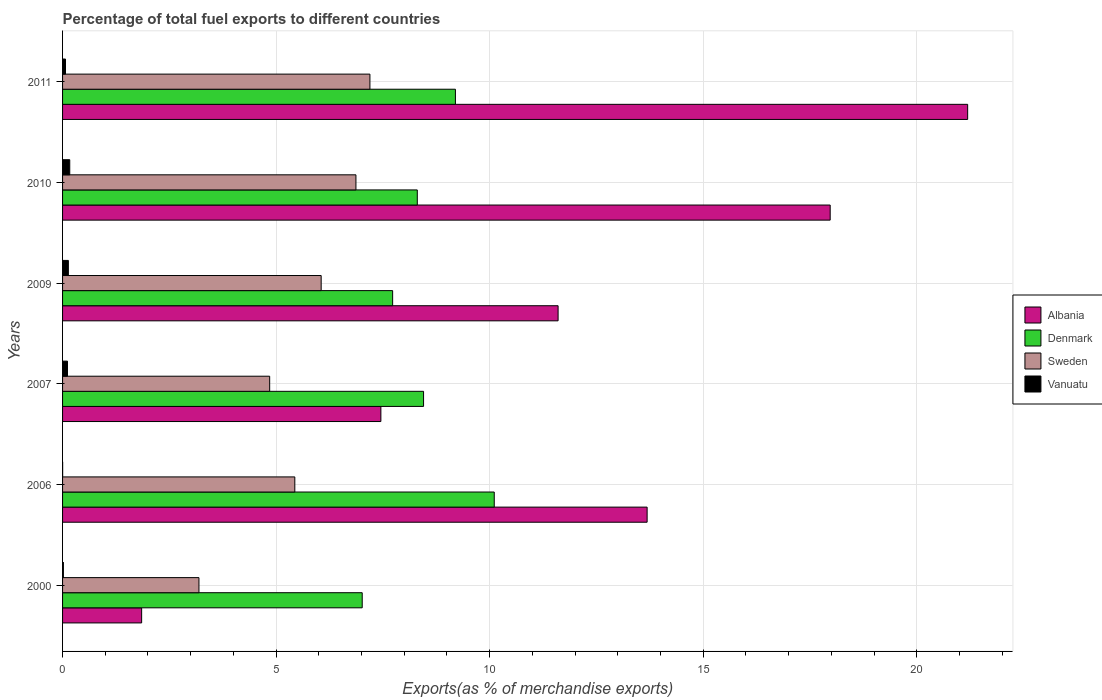How many groups of bars are there?
Your answer should be compact. 6. How many bars are there on the 1st tick from the top?
Give a very brief answer. 4. What is the percentage of exports to different countries in Sweden in 2010?
Offer a very short reply. 6.87. Across all years, what is the maximum percentage of exports to different countries in Albania?
Provide a short and direct response. 21.19. Across all years, what is the minimum percentage of exports to different countries in Sweden?
Offer a very short reply. 3.19. In which year was the percentage of exports to different countries in Sweden maximum?
Keep it short and to the point. 2011. In which year was the percentage of exports to different countries in Denmark minimum?
Your response must be concise. 2000. What is the total percentage of exports to different countries in Denmark in the graph?
Provide a succinct answer. 50.81. What is the difference between the percentage of exports to different countries in Vanuatu in 2006 and that in 2007?
Ensure brevity in your answer.  -0.11. What is the difference between the percentage of exports to different countries in Vanuatu in 2010 and the percentage of exports to different countries in Denmark in 2007?
Keep it short and to the point. -8.28. What is the average percentage of exports to different countries in Sweden per year?
Make the answer very short. 5.6. In the year 2000, what is the difference between the percentage of exports to different countries in Denmark and percentage of exports to different countries in Sweden?
Offer a very short reply. 3.82. What is the ratio of the percentage of exports to different countries in Sweden in 2000 to that in 2011?
Your answer should be compact. 0.44. Is the percentage of exports to different countries in Albania in 2000 less than that in 2010?
Your response must be concise. Yes. What is the difference between the highest and the second highest percentage of exports to different countries in Sweden?
Give a very brief answer. 0.33. What is the difference between the highest and the lowest percentage of exports to different countries in Denmark?
Keep it short and to the point. 3.09. Is it the case that in every year, the sum of the percentage of exports to different countries in Vanuatu and percentage of exports to different countries in Sweden is greater than the sum of percentage of exports to different countries in Albania and percentage of exports to different countries in Denmark?
Offer a very short reply. No. What does the 1st bar from the bottom in 2010 represents?
Offer a terse response. Albania. How many bars are there?
Your response must be concise. 24. What is the difference between two consecutive major ticks on the X-axis?
Your response must be concise. 5. Are the values on the major ticks of X-axis written in scientific E-notation?
Offer a very short reply. No. Does the graph contain any zero values?
Give a very brief answer. No. Does the graph contain grids?
Provide a short and direct response. Yes. How are the legend labels stacked?
Make the answer very short. Vertical. What is the title of the graph?
Your response must be concise. Percentage of total fuel exports to different countries. Does "Qatar" appear as one of the legend labels in the graph?
Provide a short and direct response. No. What is the label or title of the X-axis?
Provide a short and direct response. Exports(as % of merchandise exports). What is the label or title of the Y-axis?
Your response must be concise. Years. What is the Exports(as % of merchandise exports) of Albania in 2000?
Provide a short and direct response. 1.85. What is the Exports(as % of merchandise exports) of Denmark in 2000?
Offer a very short reply. 7.02. What is the Exports(as % of merchandise exports) of Sweden in 2000?
Your answer should be very brief. 3.19. What is the Exports(as % of merchandise exports) in Vanuatu in 2000?
Make the answer very short. 0.02. What is the Exports(as % of merchandise exports) of Albania in 2006?
Your answer should be compact. 13.69. What is the Exports(as % of merchandise exports) in Denmark in 2006?
Provide a short and direct response. 10.11. What is the Exports(as % of merchandise exports) of Sweden in 2006?
Make the answer very short. 5.44. What is the Exports(as % of merchandise exports) of Vanuatu in 2006?
Your answer should be compact. 0. What is the Exports(as % of merchandise exports) of Albania in 2007?
Ensure brevity in your answer.  7.45. What is the Exports(as % of merchandise exports) in Denmark in 2007?
Provide a short and direct response. 8.45. What is the Exports(as % of merchandise exports) of Sweden in 2007?
Ensure brevity in your answer.  4.85. What is the Exports(as % of merchandise exports) of Vanuatu in 2007?
Offer a very short reply. 0.12. What is the Exports(as % of merchandise exports) in Albania in 2009?
Your answer should be very brief. 11.6. What is the Exports(as % of merchandise exports) in Denmark in 2009?
Keep it short and to the point. 7.73. What is the Exports(as % of merchandise exports) of Sweden in 2009?
Offer a very short reply. 6.05. What is the Exports(as % of merchandise exports) of Vanuatu in 2009?
Make the answer very short. 0.14. What is the Exports(as % of merchandise exports) in Albania in 2010?
Give a very brief answer. 17.97. What is the Exports(as % of merchandise exports) in Denmark in 2010?
Offer a very short reply. 8.31. What is the Exports(as % of merchandise exports) in Sweden in 2010?
Ensure brevity in your answer.  6.87. What is the Exports(as % of merchandise exports) of Vanuatu in 2010?
Give a very brief answer. 0.17. What is the Exports(as % of merchandise exports) of Albania in 2011?
Ensure brevity in your answer.  21.19. What is the Exports(as % of merchandise exports) of Denmark in 2011?
Make the answer very short. 9.2. What is the Exports(as % of merchandise exports) of Sweden in 2011?
Provide a succinct answer. 7.2. What is the Exports(as % of merchandise exports) in Vanuatu in 2011?
Offer a terse response. 0.07. Across all years, what is the maximum Exports(as % of merchandise exports) in Albania?
Your response must be concise. 21.19. Across all years, what is the maximum Exports(as % of merchandise exports) of Denmark?
Provide a succinct answer. 10.11. Across all years, what is the maximum Exports(as % of merchandise exports) of Sweden?
Your answer should be compact. 7.2. Across all years, what is the maximum Exports(as % of merchandise exports) of Vanuatu?
Make the answer very short. 0.17. Across all years, what is the minimum Exports(as % of merchandise exports) in Albania?
Provide a short and direct response. 1.85. Across all years, what is the minimum Exports(as % of merchandise exports) in Denmark?
Provide a short and direct response. 7.02. Across all years, what is the minimum Exports(as % of merchandise exports) in Sweden?
Ensure brevity in your answer.  3.19. Across all years, what is the minimum Exports(as % of merchandise exports) in Vanuatu?
Make the answer very short. 0. What is the total Exports(as % of merchandise exports) in Albania in the graph?
Give a very brief answer. 73.76. What is the total Exports(as % of merchandise exports) in Denmark in the graph?
Offer a terse response. 50.81. What is the total Exports(as % of merchandise exports) of Sweden in the graph?
Make the answer very short. 33.6. What is the total Exports(as % of merchandise exports) of Vanuatu in the graph?
Offer a terse response. 0.51. What is the difference between the Exports(as % of merchandise exports) of Albania in 2000 and that in 2006?
Offer a very short reply. -11.84. What is the difference between the Exports(as % of merchandise exports) in Denmark in 2000 and that in 2006?
Provide a short and direct response. -3.09. What is the difference between the Exports(as % of merchandise exports) in Sweden in 2000 and that in 2006?
Your answer should be very brief. -2.24. What is the difference between the Exports(as % of merchandise exports) of Vanuatu in 2000 and that in 2006?
Keep it short and to the point. 0.02. What is the difference between the Exports(as % of merchandise exports) of Albania in 2000 and that in 2007?
Give a very brief answer. -5.6. What is the difference between the Exports(as % of merchandise exports) of Denmark in 2000 and that in 2007?
Ensure brevity in your answer.  -1.44. What is the difference between the Exports(as % of merchandise exports) of Sweden in 2000 and that in 2007?
Give a very brief answer. -1.66. What is the difference between the Exports(as % of merchandise exports) of Vanuatu in 2000 and that in 2007?
Ensure brevity in your answer.  -0.1. What is the difference between the Exports(as % of merchandise exports) in Albania in 2000 and that in 2009?
Your answer should be very brief. -9.75. What is the difference between the Exports(as % of merchandise exports) of Denmark in 2000 and that in 2009?
Offer a very short reply. -0.71. What is the difference between the Exports(as % of merchandise exports) of Sweden in 2000 and that in 2009?
Your answer should be compact. -2.86. What is the difference between the Exports(as % of merchandise exports) in Vanuatu in 2000 and that in 2009?
Offer a very short reply. -0.12. What is the difference between the Exports(as % of merchandise exports) in Albania in 2000 and that in 2010?
Offer a very short reply. -16.12. What is the difference between the Exports(as % of merchandise exports) of Denmark in 2000 and that in 2010?
Offer a terse response. -1.29. What is the difference between the Exports(as % of merchandise exports) of Sweden in 2000 and that in 2010?
Provide a succinct answer. -3.68. What is the difference between the Exports(as % of merchandise exports) in Vanuatu in 2000 and that in 2010?
Offer a terse response. -0.15. What is the difference between the Exports(as % of merchandise exports) in Albania in 2000 and that in 2011?
Provide a succinct answer. -19.34. What is the difference between the Exports(as % of merchandise exports) in Denmark in 2000 and that in 2011?
Your answer should be compact. -2.18. What is the difference between the Exports(as % of merchandise exports) in Sweden in 2000 and that in 2011?
Your answer should be very brief. -4. What is the difference between the Exports(as % of merchandise exports) in Vanuatu in 2000 and that in 2011?
Your response must be concise. -0.05. What is the difference between the Exports(as % of merchandise exports) of Albania in 2006 and that in 2007?
Keep it short and to the point. 6.23. What is the difference between the Exports(as % of merchandise exports) of Denmark in 2006 and that in 2007?
Make the answer very short. 1.66. What is the difference between the Exports(as % of merchandise exports) of Sweden in 2006 and that in 2007?
Your answer should be compact. 0.59. What is the difference between the Exports(as % of merchandise exports) in Vanuatu in 2006 and that in 2007?
Your response must be concise. -0.11. What is the difference between the Exports(as % of merchandise exports) of Albania in 2006 and that in 2009?
Your answer should be very brief. 2.08. What is the difference between the Exports(as % of merchandise exports) of Denmark in 2006 and that in 2009?
Ensure brevity in your answer.  2.38. What is the difference between the Exports(as % of merchandise exports) in Sweden in 2006 and that in 2009?
Provide a short and direct response. -0.62. What is the difference between the Exports(as % of merchandise exports) in Vanuatu in 2006 and that in 2009?
Ensure brevity in your answer.  -0.13. What is the difference between the Exports(as % of merchandise exports) of Albania in 2006 and that in 2010?
Your answer should be compact. -4.29. What is the difference between the Exports(as % of merchandise exports) of Denmark in 2006 and that in 2010?
Provide a short and direct response. 1.8. What is the difference between the Exports(as % of merchandise exports) of Sweden in 2006 and that in 2010?
Provide a short and direct response. -1.43. What is the difference between the Exports(as % of merchandise exports) in Vanuatu in 2006 and that in 2010?
Keep it short and to the point. -0.17. What is the difference between the Exports(as % of merchandise exports) of Albania in 2006 and that in 2011?
Offer a terse response. -7.5. What is the difference between the Exports(as % of merchandise exports) in Sweden in 2006 and that in 2011?
Keep it short and to the point. -1.76. What is the difference between the Exports(as % of merchandise exports) of Vanuatu in 2006 and that in 2011?
Your response must be concise. -0.07. What is the difference between the Exports(as % of merchandise exports) in Albania in 2007 and that in 2009?
Offer a very short reply. -4.15. What is the difference between the Exports(as % of merchandise exports) of Denmark in 2007 and that in 2009?
Ensure brevity in your answer.  0.72. What is the difference between the Exports(as % of merchandise exports) in Sweden in 2007 and that in 2009?
Provide a short and direct response. -1.21. What is the difference between the Exports(as % of merchandise exports) in Vanuatu in 2007 and that in 2009?
Keep it short and to the point. -0.02. What is the difference between the Exports(as % of merchandise exports) in Albania in 2007 and that in 2010?
Your answer should be compact. -10.52. What is the difference between the Exports(as % of merchandise exports) of Denmark in 2007 and that in 2010?
Make the answer very short. 0.15. What is the difference between the Exports(as % of merchandise exports) in Sweden in 2007 and that in 2010?
Make the answer very short. -2.02. What is the difference between the Exports(as % of merchandise exports) in Vanuatu in 2007 and that in 2010?
Offer a very short reply. -0.05. What is the difference between the Exports(as % of merchandise exports) in Albania in 2007 and that in 2011?
Your answer should be very brief. -13.74. What is the difference between the Exports(as % of merchandise exports) of Denmark in 2007 and that in 2011?
Offer a very short reply. -0.75. What is the difference between the Exports(as % of merchandise exports) in Sweden in 2007 and that in 2011?
Offer a terse response. -2.35. What is the difference between the Exports(as % of merchandise exports) in Vanuatu in 2007 and that in 2011?
Offer a terse response. 0.05. What is the difference between the Exports(as % of merchandise exports) in Albania in 2009 and that in 2010?
Offer a terse response. -6.37. What is the difference between the Exports(as % of merchandise exports) of Denmark in 2009 and that in 2010?
Give a very brief answer. -0.58. What is the difference between the Exports(as % of merchandise exports) in Sweden in 2009 and that in 2010?
Your response must be concise. -0.81. What is the difference between the Exports(as % of merchandise exports) of Vanuatu in 2009 and that in 2010?
Ensure brevity in your answer.  -0.03. What is the difference between the Exports(as % of merchandise exports) in Albania in 2009 and that in 2011?
Provide a succinct answer. -9.59. What is the difference between the Exports(as % of merchandise exports) of Denmark in 2009 and that in 2011?
Keep it short and to the point. -1.47. What is the difference between the Exports(as % of merchandise exports) in Sweden in 2009 and that in 2011?
Make the answer very short. -1.14. What is the difference between the Exports(as % of merchandise exports) in Vanuatu in 2009 and that in 2011?
Give a very brief answer. 0.07. What is the difference between the Exports(as % of merchandise exports) of Albania in 2010 and that in 2011?
Your answer should be compact. -3.22. What is the difference between the Exports(as % of merchandise exports) in Denmark in 2010 and that in 2011?
Give a very brief answer. -0.89. What is the difference between the Exports(as % of merchandise exports) in Sweden in 2010 and that in 2011?
Ensure brevity in your answer.  -0.33. What is the difference between the Exports(as % of merchandise exports) of Vanuatu in 2010 and that in 2011?
Your answer should be very brief. 0.1. What is the difference between the Exports(as % of merchandise exports) of Albania in 2000 and the Exports(as % of merchandise exports) of Denmark in 2006?
Provide a short and direct response. -8.26. What is the difference between the Exports(as % of merchandise exports) in Albania in 2000 and the Exports(as % of merchandise exports) in Sweden in 2006?
Offer a terse response. -3.59. What is the difference between the Exports(as % of merchandise exports) of Albania in 2000 and the Exports(as % of merchandise exports) of Vanuatu in 2006?
Ensure brevity in your answer.  1.85. What is the difference between the Exports(as % of merchandise exports) in Denmark in 2000 and the Exports(as % of merchandise exports) in Sweden in 2006?
Your answer should be very brief. 1.58. What is the difference between the Exports(as % of merchandise exports) in Denmark in 2000 and the Exports(as % of merchandise exports) in Vanuatu in 2006?
Offer a terse response. 7.01. What is the difference between the Exports(as % of merchandise exports) of Sweden in 2000 and the Exports(as % of merchandise exports) of Vanuatu in 2006?
Keep it short and to the point. 3.19. What is the difference between the Exports(as % of merchandise exports) in Albania in 2000 and the Exports(as % of merchandise exports) in Denmark in 2007?
Offer a terse response. -6.6. What is the difference between the Exports(as % of merchandise exports) in Albania in 2000 and the Exports(as % of merchandise exports) in Sweden in 2007?
Ensure brevity in your answer.  -3. What is the difference between the Exports(as % of merchandise exports) of Albania in 2000 and the Exports(as % of merchandise exports) of Vanuatu in 2007?
Offer a very short reply. 1.74. What is the difference between the Exports(as % of merchandise exports) of Denmark in 2000 and the Exports(as % of merchandise exports) of Sweden in 2007?
Ensure brevity in your answer.  2.17. What is the difference between the Exports(as % of merchandise exports) in Denmark in 2000 and the Exports(as % of merchandise exports) in Vanuatu in 2007?
Your answer should be very brief. 6.9. What is the difference between the Exports(as % of merchandise exports) in Sweden in 2000 and the Exports(as % of merchandise exports) in Vanuatu in 2007?
Offer a very short reply. 3.08. What is the difference between the Exports(as % of merchandise exports) in Albania in 2000 and the Exports(as % of merchandise exports) in Denmark in 2009?
Your response must be concise. -5.88. What is the difference between the Exports(as % of merchandise exports) of Albania in 2000 and the Exports(as % of merchandise exports) of Sweden in 2009?
Ensure brevity in your answer.  -4.2. What is the difference between the Exports(as % of merchandise exports) in Albania in 2000 and the Exports(as % of merchandise exports) in Vanuatu in 2009?
Offer a terse response. 1.72. What is the difference between the Exports(as % of merchandise exports) in Denmark in 2000 and the Exports(as % of merchandise exports) in Sweden in 2009?
Provide a short and direct response. 0.96. What is the difference between the Exports(as % of merchandise exports) in Denmark in 2000 and the Exports(as % of merchandise exports) in Vanuatu in 2009?
Your answer should be compact. 6.88. What is the difference between the Exports(as % of merchandise exports) of Sweden in 2000 and the Exports(as % of merchandise exports) of Vanuatu in 2009?
Make the answer very short. 3.06. What is the difference between the Exports(as % of merchandise exports) of Albania in 2000 and the Exports(as % of merchandise exports) of Denmark in 2010?
Give a very brief answer. -6.45. What is the difference between the Exports(as % of merchandise exports) of Albania in 2000 and the Exports(as % of merchandise exports) of Sweden in 2010?
Your answer should be compact. -5.02. What is the difference between the Exports(as % of merchandise exports) in Albania in 2000 and the Exports(as % of merchandise exports) in Vanuatu in 2010?
Your answer should be compact. 1.68. What is the difference between the Exports(as % of merchandise exports) of Denmark in 2000 and the Exports(as % of merchandise exports) of Sweden in 2010?
Offer a very short reply. 0.15. What is the difference between the Exports(as % of merchandise exports) in Denmark in 2000 and the Exports(as % of merchandise exports) in Vanuatu in 2010?
Your answer should be compact. 6.85. What is the difference between the Exports(as % of merchandise exports) of Sweden in 2000 and the Exports(as % of merchandise exports) of Vanuatu in 2010?
Give a very brief answer. 3.03. What is the difference between the Exports(as % of merchandise exports) in Albania in 2000 and the Exports(as % of merchandise exports) in Denmark in 2011?
Your answer should be very brief. -7.35. What is the difference between the Exports(as % of merchandise exports) of Albania in 2000 and the Exports(as % of merchandise exports) of Sweden in 2011?
Your answer should be compact. -5.34. What is the difference between the Exports(as % of merchandise exports) in Albania in 2000 and the Exports(as % of merchandise exports) in Vanuatu in 2011?
Provide a short and direct response. 1.78. What is the difference between the Exports(as % of merchandise exports) in Denmark in 2000 and the Exports(as % of merchandise exports) in Sweden in 2011?
Ensure brevity in your answer.  -0.18. What is the difference between the Exports(as % of merchandise exports) of Denmark in 2000 and the Exports(as % of merchandise exports) of Vanuatu in 2011?
Your answer should be compact. 6.95. What is the difference between the Exports(as % of merchandise exports) in Sweden in 2000 and the Exports(as % of merchandise exports) in Vanuatu in 2011?
Offer a very short reply. 3.12. What is the difference between the Exports(as % of merchandise exports) of Albania in 2006 and the Exports(as % of merchandise exports) of Denmark in 2007?
Make the answer very short. 5.23. What is the difference between the Exports(as % of merchandise exports) in Albania in 2006 and the Exports(as % of merchandise exports) in Sweden in 2007?
Make the answer very short. 8.84. What is the difference between the Exports(as % of merchandise exports) in Albania in 2006 and the Exports(as % of merchandise exports) in Vanuatu in 2007?
Your answer should be compact. 13.57. What is the difference between the Exports(as % of merchandise exports) of Denmark in 2006 and the Exports(as % of merchandise exports) of Sweden in 2007?
Offer a terse response. 5.26. What is the difference between the Exports(as % of merchandise exports) in Denmark in 2006 and the Exports(as % of merchandise exports) in Vanuatu in 2007?
Provide a succinct answer. 9.99. What is the difference between the Exports(as % of merchandise exports) in Sweden in 2006 and the Exports(as % of merchandise exports) in Vanuatu in 2007?
Your response must be concise. 5.32. What is the difference between the Exports(as % of merchandise exports) in Albania in 2006 and the Exports(as % of merchandise exports) in Denmark in 2009?
Make the answer very short. 5.96. What is the difference between the Exports(as % of merchandise exports) in Albania in 2006 and the Exports(as % of merchandise exports) in Sweden in 2009?
Provide a short and direct response. 7.63. What is the difference between the Exports(as % of merchandise exports) in Albania in 2006 and the Exports(as % of merchandise exports) in Vanuatu in 2009?
Keep it short and to the point. 13.55. What is the difference between the Exports(as % of merchandise exports) in Denmark in 2006 and the Exports(as % of merchandise exports) in Sweden in 2009?
Provide a succinct answer. 4.05. What is the difference between the Exports(as % of merchandise exports) of Denmark in 2006 and the Exports(as % of merchandise exports) of Vanuatu in 2009?
Provide a short and direct response. 9.97. What is the difference between the Exports(as % of merchandise exports) of Sweden in 2006 and the Exports(as % of merchandise exports) of Vanuatu in 2009?
Ensure brevity in your answer.  5.3. What is the difference between the Exports(as % of merchandise exports) in Albania in 2006 and the Exports(as % of merchandise exports) in Denmark in 2010?
Ensure brevity in your answer.  5.38. What is the difference between the Exports(as % of merchandise exports) in Albania in 2006 and the Exports(as % of merchandise exports) in Sweden in 2010?
Ensure brevity in your answer.  6.82. What is the difference between the Exports(as % of merchandise exports) of Albania in 2006 and the Exports(as % of merchandise exports) of Vanuatu in 2010?
Your response must be concise. 13.52. What is the difference between the Exports(as % of merchandise exports) of Denmark in 2006 and the Exports(as % of merchandise exports) of Sweden in 2010?
Offer a terse response. 3.24. What is the difference between the Exports(as % of merchandise exports) of Denmark in 2006 and the Exports(as % of merchandise exports) of Vanuatu in 2010?
Your answer should be very brief. 9.94. What is the difference between the Exports(as % of merchandise exports) of Sweden in 2006 and the Exports(as % of merchandise exports) of Vanuatu in 2010?
Offer a very short reply. 5.27. What is the difference between the Exports(as % of merchandise exports) of Albania in 2006 and the Exports(as % of merchandise exports) of Denmark in 2011?
Give a very brief answer. 4.49. What is the difference between the Exports(as % of merchandise exports) in Albania in 2006 and the Exports(as % of merchandise exports) in Sweden in 2011?
Your answer should be compact. 6.49. What is the difference between the Exports(as % of merchandise exports) in Albania in 2006 and the Exports(as % of merchandise exports) in Vanuatu in 2011?
Provide a short and direct response. 13.62. What is the difference between the Exports(as % of merchandise exports) of Denmark in 2006 and the Exports(as % of merchandise exports) of Sweden in 2011?
Provide a short and direct response. 2.91. What is the difference between the Exports(as % of merchandise exports) in Denmark in 2006 and the Exports(as % of merchandise exports) in Vanuatu in 2011?
Your answer should be compact. 10.04. What is the difference between the Exports(as % of merchandise exports) of Sweden in 2006 and the Exports(as % of merchandise exports) of Vanuatu in 2011?
Ensure brevity in your answer.  5.37. What is the difference between the Exports(as % of merchandise exports) in Albania in 2007 and the Exports(as % of merchandise exports) in Denmark in 2009?
Provide a short and direct response. -0.28. What is the difference between the Exports(as % of merchandise exports) in Albania in 2007 and the Exports(as % of merchandise exports) in Sweden in 2009?
Keep it short and to the point. 1.4. What is the difference between the Exports(as % of merchandise exports) of Albania in 2007 and the Exports(as % of merchandise exports) of Vanuatu in 2009?
Your response must be concise. 7.32. What is the difference between the Exports(as % of merchandise exports) in Denmark in 2007 and the Exports(as % of merchandise exports) in Sweden in 2009?
Ensure brevity in your answer.  2.4. What is the difference between the Exports(as % of merchandise exports) in Denmark in 2007 and the Exports(as % of merchandise exports) in Vanuatu in 2009?
Provide a succinct answer. 8.32. What is the difference between the Exports(as % of merchandise exports) of Sweden in 2007 and the Exports(as % of merchandise exports) of Vanuatu in 2009?
Offer a terse response. 4.71. What is the difference between the Exports(as % of merchandise exports) of Albania in 2007 and the Exports(as % of merchandise exports) of Denmark in 2010?
Make the answer very short. -0.85. What is the difference between the Exports(as % of merchandise exports) of Albania in 2007 and the Exports(as % of merchandise exports) of Sweden in 2010?
Give a very brief answer. 0.58. What is the difference between the Exports(as % of merchandise exports) of Albania in 2007 and the Exports(as % of merchandise exports) of Vanuatu in 2010?
Provide a succinct answer. 7.28. What is the difference between the Exports(as % of merchandise exports) of Denmark in 2007 and the Exports(as % of merchandise exports) of Sweden in 2010?
Your answer should be very brief. 1.58. What is the difference between the Exports(as % of merchandise exports) of Denmark in 2007 and the Exports(as % of merchandise exports) of Vanuatu in 2010?
Offer a very short reply. 8.28. What is the difference between the Exports(as % of merchandise exports) of Sweden in 2007 and the Exports(as % of merchandise exports) of Vanuatu in 2010?
Offer a terse response. 4.68. What is the difference between the Exports(as % of merchandise exports) in Albania in 2007 and the Exports(as % of merchandise exports) in Denmark in 2011?
Your answer should be very brief. -1.75. What is the difference between the Exports(as % of merchandise exports) of Albania in 2007 and the Exports(as % of merchandise exports) of Sweden in 2011?
Provide a succinct answer. 0.26. What is the difference between the Exports(as % of merchandise exports) of Albania in 2007 and the Exports(as % of merchandise exports) of Vanuatu in 2011?
Provide a succinct answer. 7.38. What is the difference between the Exports(as % of merchandise exports) in Denmark in 2007 and the Exports(as % of merchandise exports) in Sweden in 2011?
Keep it short and to the point. 1.26. What is the difference between the Exports(as % of merchandise exports) of Denmark in 2007 and the Exports(as % of merchandise exports) of Vanuatu in 2011?
Your response must be concise. 8.38. What is the difference between the Exports(as % of merchandise exports) of Sweden in 2007 and the Exports(as % of merchandise exports) of Vanuatu in 2011?
Give a very brief answer. 4.78. What is the difference between the Exports(as % of merchandise exports) of Albania in 2009 and the Exports(as % of merchandise exports) of Denmark in 2010?
Provide a succinct answer. 3.3. What is the difference between the Exports(as % of merchandise exports) of Albania in 2009 and the Exports(as % of merchandise exports) of Sweden in 2010?
Provide a succinct answer. 4.73. What is the difference between the Exports(as % of merchandise exports) in Albania in 2009 and the Exports(as % of merchandise exports) in Vanuatu in 2010?
Make the answer very short. 11.43. What is the difference between the Exports(as % of merchandise exports) in Denmark in 2009 and the Exports(as % of merchandise exports) in Sweden in 2010?
Offer a terse response. 0.86. What is the difference between the Exports(as % of merchandise exports) in Denmark in 2009 and the Exports(as % of merchandise exports) in Vanuatu in 2010?
Offer a very short reply. 7.56. What is the difference between the Exports(as % of merchandise exports) of Sweden in 2009 and the Exports(as % of merchandise exports) of Vanuatu in 2010?
Offer a very short reply. 5.89. What is the difference between the Exports(as % of merchandise exports) of Albania in 2009 and the Exports(as % of merchandise exports) of Denmark in 2011?
Your answer should be very brief. 2.4. What is the difference between the Exports(as % of merchandise exports) in Albania in 2009 and the Exports(as % of merchandise exports) in Sweden in 2011?
Your answer should be very brief. 4.41. What is the difference between the Exports(as % of merchandise exports) in Albania in 2009 and the Exports(as % of merchandise exports) in Vanuatu in 2011?
Your answer should be compact. 11.53. What is the difference between the Exports(as % of merchandise exports) in Denmark in 2009 and the Exports(as % of merchandise exports) in Sweden in 2011?
Your answer should be compact. 0.53. What is the difference between the Exports(as % of merchandise exports) of Denmark in 2009 and the Exports(as % of merchandise exports) of Vanuatu in 2011?
Offer a terse response. 7.66. What is the difference between the Exports(as % of merchandise exports) of Sweden in 2009 and the Exports(as % of merchandise exports) of Vanuatu in 2011?
Your answer should be very brief. 5.99. What is the difference between the Exports(as % of merchandise exports) in Albania in 2010 and the Exports(as % of merchandise exports) in Denmark in 2011?
Give a very brief answer. 8.77. What is the difference between the Exports(as % of merchandise exports) of Albania in 2010 and the Exports(as % of merchandise exports) of Sweden in 2011?
Your answer should be compact. 10.78. What is the difference between the Exports(as % of merchandise exports) in Albania in 2010 and the Exports(as % of merchandise exports) in Vanuatu in 2011?
Your response must be concise. 17.9. What is the difference between the Exports(as % of merchandise exports) of Denmark in 2010 and the Exports(as % of merchandise exports) of Sweden in 2011?
Your answer should be very brief. 1.11. What is the difference between the Exports(as % of merchandise exports) of Denmark in 2010 and the Exports(as % of merchandise exports) of Vanuatu in 2011?
Give a very brief answer. 8.24. What is the difference between the Exports(as % of merchandise exports) in Sweden in 2010 and the Exports(as % of merchandise exports) in Vanuatu in 2011?
Offer a terse response. 6.8. What is the average Exports(as % of merchandise exports) of Albania per year?
Offer a very short reply. 12.29. What is the average Exports(as % of merchandise exports) in Denmark per year?
Give a very brief answer. 8.47. What is the average Exports(as % of merchandise exports) in Sweden per year?
Provide a short and direct response. 5.6. What is the average Exports(as % of merchandise exports) of Vanuatu per year?
Offer a very short reply. 0.08. In the year 2000, what is the difference between the Exports(as % of merchandise exports) in Albania and Exports(as % of merchandise exports) in Denmark?
Offer a very short reply. -5.16. In the year 2000, what is the difference between the Exports(as % of merchandise exports) of Albania and Exports(as % of merchandise exports) of Sweden?
Offer a very short reply. -1.34. In the year 2000, what is the difference between the Exports(as % of merchandise exports) of Albania and Exports(as % of merchandise exports) of Vanuatu?
Offer a terse response. 1.83. In the year 2000, what is the difference between the Exports(as % of merchandise exports) of Denmark and Exports(as % of merchandise exports) of Sweden?
Your answer should be compact. 3.82. In the year 2000, what is the difference between the Exports(as % of merchandise exports) of Denmark and Exports(as % of merchandise exports) of Vanuatu?
Your response must be concise. 7. In the year 2000, what is the difference between the Exports(as % of merchandise exports) in Sweden and Exports(as % of merchandise exports) in Vanuatu?
Provide a succinct answer. 3.17. In the year 2006, what is the difference between the Exports(as % of merchandise exports) in Albania and Exports(as % of merchandise exports) in Denmark?
Provide a short and direct response. 3.58. In the year 2006, what is the difference between the Exports(as % of merchandise exports) of Albania and Exports(as % of merchandise exports) of Sweden?
Provide a succinct answer. 8.25. In the year 2006, what is the difference between the Exports(as % of merchandise exports) of Albania and Exports(as % of merchandise exports) of Vanuatu?
Offer a very short reply. 13.69. In the year 2006, what is the difference between the Exports(as % of merchandise exports) in Denmark and Exports(as % of merchandise exports) in Sweden?
Make the answer very short. 4.67. In the year 2006, what is the difference between the Exports(as % of merchandise exports) of Denmark and Exports(as % of merchandise exports) of Vanuatu?
Provide a succinct answer. 10.11. In the year 2006, what is the difference between the Exports(as % of merchandise exports) of Sweden and Exports(as % of merchandise exports) of Vanuatu?
Your response must be concise. 5.44. In the year 2007, what is the difference between the Exports(as % of merchandise exports) in Albania and Exports(as % of merchandise exports) in Denmark?
Your answer should be very brief. -1. In the year 2007, what is the difference between the Exports(as % of merchandise exports) in Albania and Exports(as % of merchandise exports) in Sweden?
Your answer should be very brief. 2.6. In the year 2007, what is the difference between the Exports(as % of merchandise exports) of Albania and Exports(as % of merchandise exports) of Vanuatu?
Your answer should be very brief. 7.34. In the year 2007, what is the difference between the Exports(as % of merchandise exports) of Denmark and Exports(as % of merchandise exports) of Sweden?
Offer a terse response. 3.6. In the year 2007, what is the difference between the Exports(as % of merchandise exports) of Denmark and Exports(as % of merchandise exports) of Vanuatu?
Give a very brief answer. 8.34. In the year 2007, what is the difference between the Exports(as % of merchandise exports) of Sweden and Exports(as % of merchandise exports) of Vanuatu?
Ensure brevity in your answer.  4.73. In the year 2009, what is the difference between the Exports(as % of merchandise exports) in Albania and Exports(as % of merchandise exports) in Denmark?
Keep it short and to the point. 3.87. In the year 2009, what is the difference between the Exports(as % of merchandise exports) in Albania and Exports(as % of merchandise exports) in Sweden?
Your response must be concise. 5.55. In the year 2009, what is the difference between the Exports(as % of merchandise exports) in Albania and Exports(as % of merchandise exports) in Vanuatu?
Provide a succinct answer. 11.47. In the year 2009, what is the difference between the Exports(as % of merchandise exports) of Denmark and Exports(as % of merchandise exports) of Sweden?
Your answer should be very brief. 1.67. In the year 2009, what is the difference between the Exports(as % of merchandise exports) in Denmark and Exports(as % of merchandise exports) in Vanuatu?
Give a very brief answer. 7.59. In the year 2009, what is the difference between the Exports(as % of merchandise exports) in Sweden and Exports(as % of merchandise exports) in Vanuatu?
Your answer should be compact. 5.92. In the year 2010, what is the difference between the Exports(as % of merchandise exports) in Albania and Exports(as % of merchandise exports) in Denmark?
Provide a succinct answer. 9.67. In the year 2010, what is the difference between the Exports(as % of merchandise exports) in Albania and Exports(as % of merchandise exports) in Sweden?
Make the answer very short. 11.1. In the year 2010, what is the difference between the Exports(as % of merchandise exports) in Albania and Exports(as % of merchandise exports) in Vanuatu?
Your response must be concise. 17.81. In the year 2010, what is the difference between the Exports(as % of merchandise exports) in Denmark and Exports(as % of merchandise exports) in Sweden?
Ensure brevity in your answer.  1.44. In the year 2010, what is the difference between the Exports(as % of merchandise exports) in Denmark and Exports(as % of merchandise exports) in Vanuatu?
Provide a succinct answer. 8.14. In the year 2010, what is the difference between the Exports(as % of merchandise exports) in Sweden and Exports(as % of merchandise exports) in Vanuatu?
Offer a very short reply. 6.7. In the year 2011, what is the difference between the Exports(as % of merchandise exports) in Albania and Exports(as % of merchandise exports) in Denmark?
Provide a short and direct response. 11.99. In the year 2011, what is the difference between the Exports(as % of merchandise exports) of Albania and Exports(as % of merchandise exports) of Sweden?
Provide a succinct answer. 14. In the year 2011, what is the difference between the Exports(as % of merchandise exports) of Albania and Exports(as % of merchandise exports) of Vanuatu?
Offer a very short reply. 21.12. In the year 2011, what is the difference between the Exports(as % of merchandise exports) of Denmark and Exports(as % of merchandise exports) of Sweden?
Give a very brief answer. 2. In the year 2011, what is the difference between the Exports(as % of merchandise exports) of Denmark and Exports(as % of merchandise exports) of Vanuatu?
Provide a succinct answer. 9.13. In the year 2011, what is the difference between the Exports(as % of merchandise exports) of Sweden and Exports(as % of merchandise exports) of Vanuatu?
Your answer should be very brief. 7.13. What is the ratio of the Exports(as % of merchandise exports) of Albania in 2000 to that in 2006?
Provide a succinct answer. 0.14. What is the ratio of the Exports(as % of merchandise exports) in Denmark in 2000 to that in 2006?
Provide a succinct answer. 0.69. What is the ratio of the Exports(as % of merchandise exports) of Sweden in 2000 to that in 2006?
Your response must be concise. 0.59. What is the ratio of the Exports(as % of merchandise exports) in Vanuatu in 2000 to that in 2006?
Provide a short and direct response. 10.53. What is the ratio of the Exports(as % of merchandise exports) of Albania in 2000 to that in 2007?
Keep it short and to the point. 0.25. What is the ratio of the Exports(as % of merchandise exports) in Denmark in 2000 to that in 2007?
Make the answer very short. 0.83. What is the ratio of the Exports(as % of merchandise exports) of Sweden in 2000 to that in 2007?
Your answer should be compact. 0.66. What is the ratio of the Exports(as % of merchandise exports) in Vanuatu in 2000 to that in 2007?
Offer a terse response. 0.17. What is the ratio of the Exports(as % of merchandise exports) of Albania in 2000 to that in 2009?
Offer a very short reply. 0.16. What is the ratio of the Exports(as % of merchandise exports) of Denmark in 2000 to that in 2009?
Give a very brief answer. 0.91. What is the ratio of the Exports(as % of merchandise exports) of Sweden in 2000 to that in 2009?
Your response must be concise. 0.53. What is the ratio of the Exports(as % of merchandise exports) of Vanuatu in 2000 to that in 2009?
Give a very brief answer. 0.14. What is the ratio of the Exports(as % of merchandise exports) of Albania in 2000 to that in 2010?
Your response must be concise. 0.1. What is the ratio of the Exports(as % of merchandise exports) of Denmark in 2000 to that in 2010?
Your response must be concise. 0.84. What is the ratio of the Exports(as % of merchandise exports) of Sweden in 2000 to that in 2010?
Your answer should be compact. 0.46. What is the ratio of the Exports(as % of merchandise exports) of Vanuatu in 2000 to that in 2010?
Provide a short and direct response. 0.12. What is the ratio of the Exports(as % of merchandise exports) of Albania in 2000 to that in 2011?
Your response must be concise. 0.09. What is the ratio of the Exports(as % of merchandise exports) of Denmark in 2000 to that in 2011?
Ensure brevity in your answer.  0.76. What is the ratio of the Exports(as % of merchandise exports) in Sweden in 2000 to that in 2011?
Your response must be concise. 0.44. What is the ratio of the Exports(as % of merchandise exports) in Vanuatu in 2000 to that in 2011?
Make the answer very short. 0.29. What is the ratio of the Exports(as % of merchandise exports) of Albania in 2006 to that in 2007?
Ensure brevity in your answer.  1.84. What is the ratio of the Exports(as % of merchandise exports) in Denmark in 2006 to that in 2007?
Keep it short and to the point. 1.2. What is the ratio of the Exports(as % of merchandise exports) of Sweden in 2006 to that in 2007?
Offer a terse response. 1.12. What is the ratio of the Exports(as % of merchandise exports) in Vanuatu in 2006 to that in 2007?
Your answer should be compact. 0.02. What is the ratio of the Exports(as % of merchandise exports) of Albania in 2006 to that in 2009?
Provide a succinct answer. 1.18. What is the ratio of the Exports(as % of merchandise exports) of Denmark in 2006 to that in 2009?
Provide a short and direct response. 1.31. What is the ratio of the Exports(as % of merchandise exports) of Sweden in 2006 to that in 2009?
Your response must be concise. 0.9. What is the ratio of the Exports(as % of merchandise exports) in Vanuatu in 2006 to that in 2009?
Provide a short and direct response. 0.01. What is the ratio of the Exports(as % of merchandise exports) in Albania in 2006 to that in 2010?
Keep it short and to the point. 0.76. What is the ratio of the Exports(as % of merchandise exports) of Denmark in 2006 to that in 2010?
Offer a terse response. 1.22. What is the ratio of the Exports(as % of merchandise exports) in Sweden in 2006 to that in 2010?
Give a very brief answer. 0.79. What is the ratio of the Exports(as % of merchandise exports) in Vanuatu in 2006 to that in 2010?
Give a very brief answer. 0.01. What is the ratio of the Exports(as % of merchandise exports) of Albania in 2006 to that in 2011?
Give a very brief answer. 0.65. What is the ratio of the Exports(as % of merchandise exports) of Denmark in 2006 to that in 2011?
Ensure brevity in your answer.  1.1. What is the ratio of the Exports(as % of merchandise exports) in Sweden in 2006 to that in 2011?
Offer a terse response. 0.76. What is the ratio of the Exports(as % of merchandise exports) of Vanuatu in 2006 to that in 2011?
Provide a short and direct response. 0.03. What is the ratio of the Exports(as % of merchandise exports) in Albania in 2007 to that in 2009?
Your answer should be compact. 0.64. What is the ratio of the Exports(as % of merchandise exports) of Denmark in 2007 to that in 2009?
Keep it short and to the point. 1.09. What is the ratio of the Exports(as % of merchandise exports) in Sweden in 2007 to that in 2009?
Your answer should be very brief. 0.8. What is the ratio of the Exports(as % of merchandise exports) in Vanuatu in 2007 to that in 2009?
Your response must be concise. 0.85. What is the ratio of the Exports(as % of merchandise exports) of Albania in 2007 to that in 2010?
Your answer should be very brief. 0.41. What is the ratio of the Exports(as % of merchandise exports) in Denmark in 2007 to that in 2010?
Offer a very short reply. 1.02. What is the ratio of the Exports(as % of merchandise exports) of Sweden in 2007 to that in 2010?
Offer a terse response. 0.71. What is the ratio of the Exports(as % of merchandise exports) in Vanuatu in 2007 to that in 2010?
Provide a succinct answer. 0.69. What is the ratio of the Exports(as % of merchandise exports) in Albania in 2007 to that in 2011?
Provide a succinct answer. 0.35. What is the ratio of the Exports(as % of merchandise exports) of Denmark in 2007 to that in 2011?
Your response must be concise. 0.92. What is the ratio of the Exports(as % of merchandise exports) in Sweden in 2007 to that in 2011?
Your answer should be very brief. 0.67. What is the ratio of the Exports(as % of merchandise exports) of Vanuatu in 2007 to that in 2011?
Offer a terse response. 1.68. What is the ratio of the Exports(as % of merchandise exports) of Albania in 2009 to that in 2010?
Provide a short and direct response. 0.65. What is the ratio of the Exports(as % of merchandise exports) of Denmark in 2009 to that in 2010?
Your answer should be compact. 0.93. What is the ratio of the Exports(as % of merchandise exports) in Sweden in 2009 to that in 2010?
Offer a terse response. 0.88. What is the ratio of the Exports(as % of merchandise exports) of Vanuatu in 2009 to that in 2010?
Your answer should be very brief. 0.81. What is the ratio of the Exports(as % of merchandise exports) of Albania in 2009 to that in 2011?
Provide a succinct answer. 0.55. What is the ratio of the Exports(as % of merchandise exports) in Denmark in 2009 to that in 2011?
Provide a succinct answer. 0.84. What is the ratio of the Exports(as % of merchandise exports) of Sweden in 2009 to that in 2011?
Offer a very short reply. 0.84. What is the ratio of the Exports(as % of merchandise exports) of Vanuatu in 2009 to that in 2011?
Make the answer very short. 1.97. What is the ratio of the Exports(as % of merchandise exports) of Albania in 2010 to that in 2011?
Your answer should be compact. 0.85. What is the ratio of the Exports(as % of merchandise exports) of Denmark in 2010 to that in 2011?
Keep it short and to the point. 0.9. What is the ratio of the Exports(as % of merchandise exports) in Sweden in 2010 to that in 2011?
Offer a very short reply. 0.95. What is the ratio of the Exports(as % of merchandise exports) of Vanuatu in 2010 to that in 2011?
Offer a terse response. 2.45. What is the difference between the highest and the second highest Exports(as % of merchandise exports) in Albania?
Offer a very short reply. 3.22. What is the difference between the highest and the second highest Exports(as % of merchandise exports) in Sweden?
Provide a short and direct response. 0.33. What is the difference between the highest and the second highest Exports(as % of merchandise exports) in Vanuatu?
Offer a very short reply. 0.03. What is the difference between the highest and the lowest Exports(as % of merchandise exports) in Albania?
Give a very brief answer. 19.34. What is the difference between the highest and the lowest Exports(as % of merchandise exports) in Denmark?
Make the answer very short. 3.09. What is the difference between the highest and the lowest Exports(as % of merchandise exports) of Sweden?
Provide a succinct answer. 4. What is the difference between the highest and the lowest Exports(as % of merchandise exports) in Vanuatu?
Give a very brief answer. 0.17. 